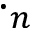<formula> <loc_0><loc_0><loc_500><loc_500>\cdot _ { n }</formula> 